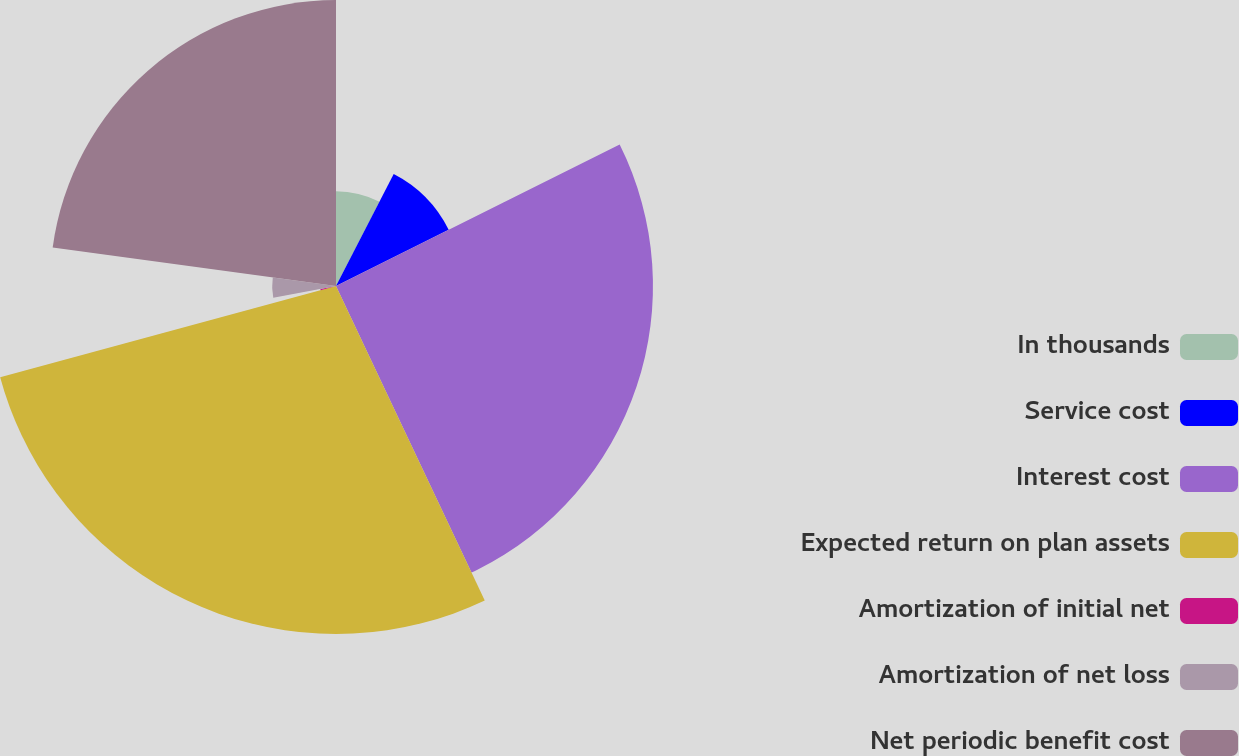<chart> <loc_0><loc_0><loc_500><loc_500><pie_chart><fcel>In thousands<fcel>Service cost<fcel>Interest cost<fcel>Expected return on plan assets<fcel>Amortization of initial net<fcel>Amortization of net loss<fcel>Net periodic benefit cost<nl><fcel>7.58%<fcel>10.06%<fcel>25.33%<fcel>27.81%<fcel>1.27%<fcel>5.1%<fcel>22.85%<nl></chart> 